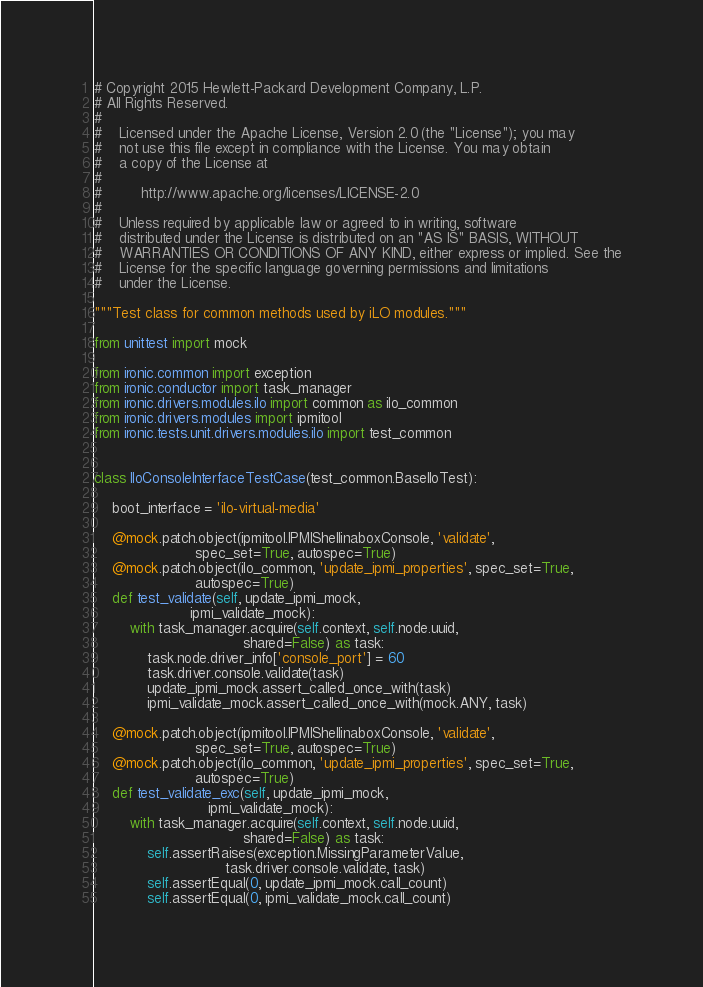Convert code to text. <code><loc_0><loc_0><loc_500><loc_500><_Python_># Copyright 2015 Hewlett-Packard Development Company, L.P.
# All Rights Reserved.
#
#    Licensed under the Apache License, Version 2.0 (the "License"); you may
#    not use this file except in compliance with the License. You may obtain
#    a copy of the License at
#
#         http://www.apache.org/licenses/LICENSE-2.0
#
#    Unless required by applicable law or agreed to in writing, software
#    distributed under the License is distributed on an "AS IS" BASIS, WITHOUT
#    WARRANTIES OR CONDITIONS OF ANY KIND, either express or implied. See the
#    License for the specific language governing permissions and limitations
#    under the License.

"""Test class for common methods used by iLO modules."""

from unittest import mock

from ironic.common import exception
from ironic.conductor import task_manager
from ironic.drivers.modules.ilo import common as ilo_common
from ironic.drivers.modules import ipmitool
from ironic.tests.unit.drivers.modules.ilo import test_common


class IloConsoleInterfaceTestCase(test_common.BaseIloTest):

    boot_interface = 'ilo-virtual-media'

    @mock.patch.object(ipmitool.IPMIShellinaboxConsole, 'validate',
                       spec_set=True, autospec=True)
    @mock.patch.object(ilo_common, 'update_ipmi_properties', spec_set=True,
                       autospec=True)
    def test_validate(self, update_ipmi_mock,
                      ipmi_validate_mock):
        with task_manager.acquire(self.context, self.node.uuid,
                                  shared=False) as task:
            task.node.driver_info['console_port'] = 60
            task.driver.console.validate(task)
            update_ipmi_mock.assert_called_once_with(task)
            ipmi_validate_mock.assert_called_once_with(mock.ANY, task)

    @mock.patch.object(ipmitool.IPMIShellinaboxConsole, 'validate',
                       spec_set=True, autospec=True)
    @mock.patch.object(ilo_common, 'update_ipmi_properties', spec_set=True,
                       autospec=True)
    def test_validate_exc(self, update_ipmi_mock,
                          ipmi_validate_mock):
        with task_manager.acquire(self.context, self.node.uuid,
                                  shared=False) as task:
            self.assertRaises(exception.MissingParameterValue,
                              task.driver.console.validate, task)
            self.assertEqual(0, update_ipmi_mock.call_count)
            self.assertEqual(0, ipmi_validate_mock.call_count)
</code> 